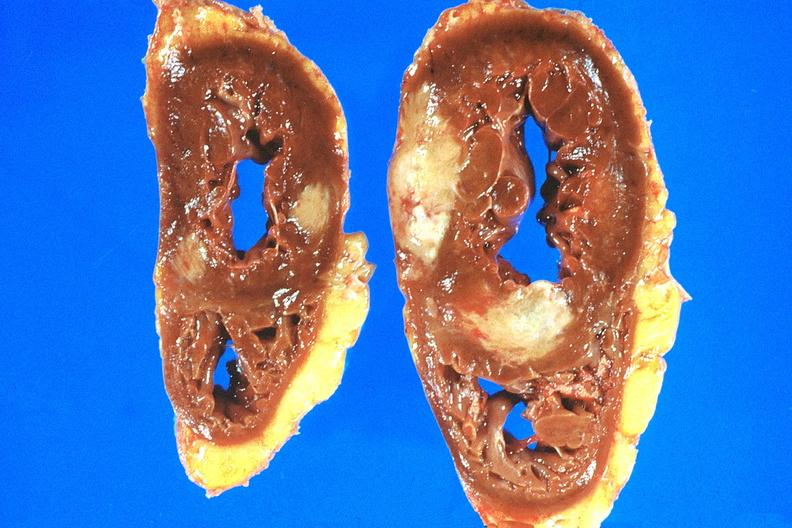where is this?
Answer the question using a single word or phrase. Heart 